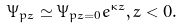<formula> <loc_0><loc_0><loc_500><loc_500>\Psi _ { p z } \simeq \Psi _ { p z = 0 } e ^ { \kappa z } , z < 0 .</formula> 